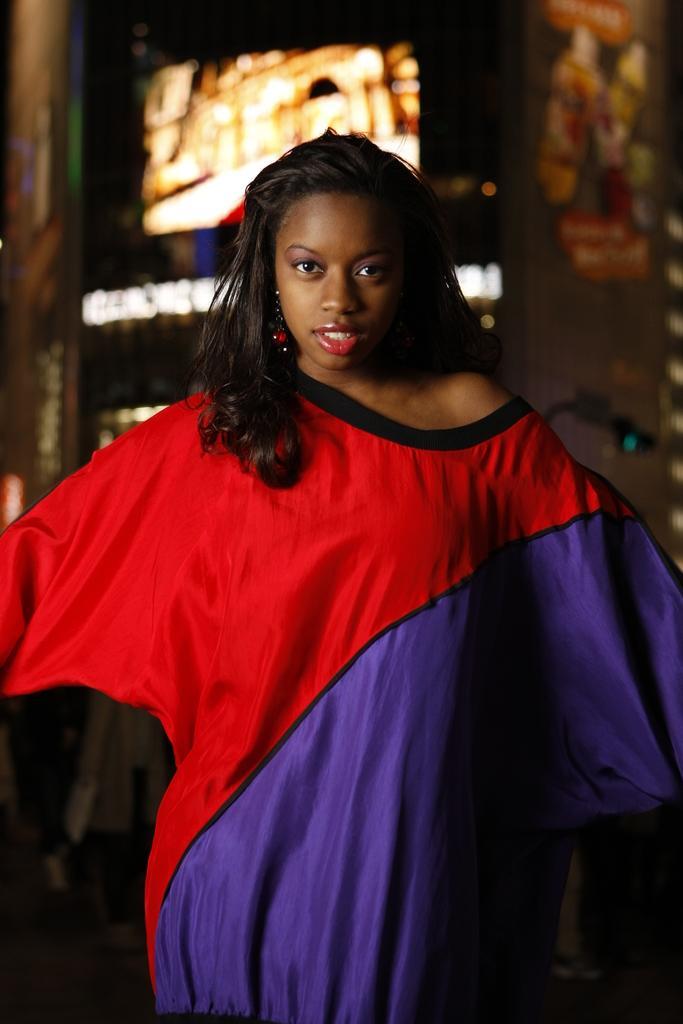In one or two sentences, can you explain what this image depicts? In this image we can see a woman standing. On the backside we can see some lights. 